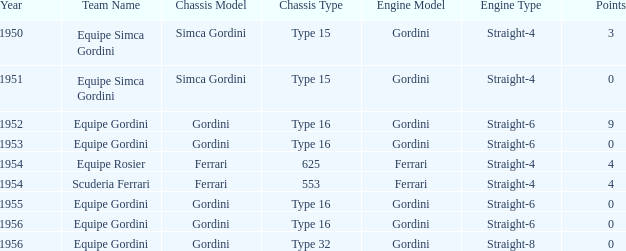What engine was used by Equipe Simca Gordini before 1956 with less than 4 points? Gordini Straight-4, Gordini Straight-4. 